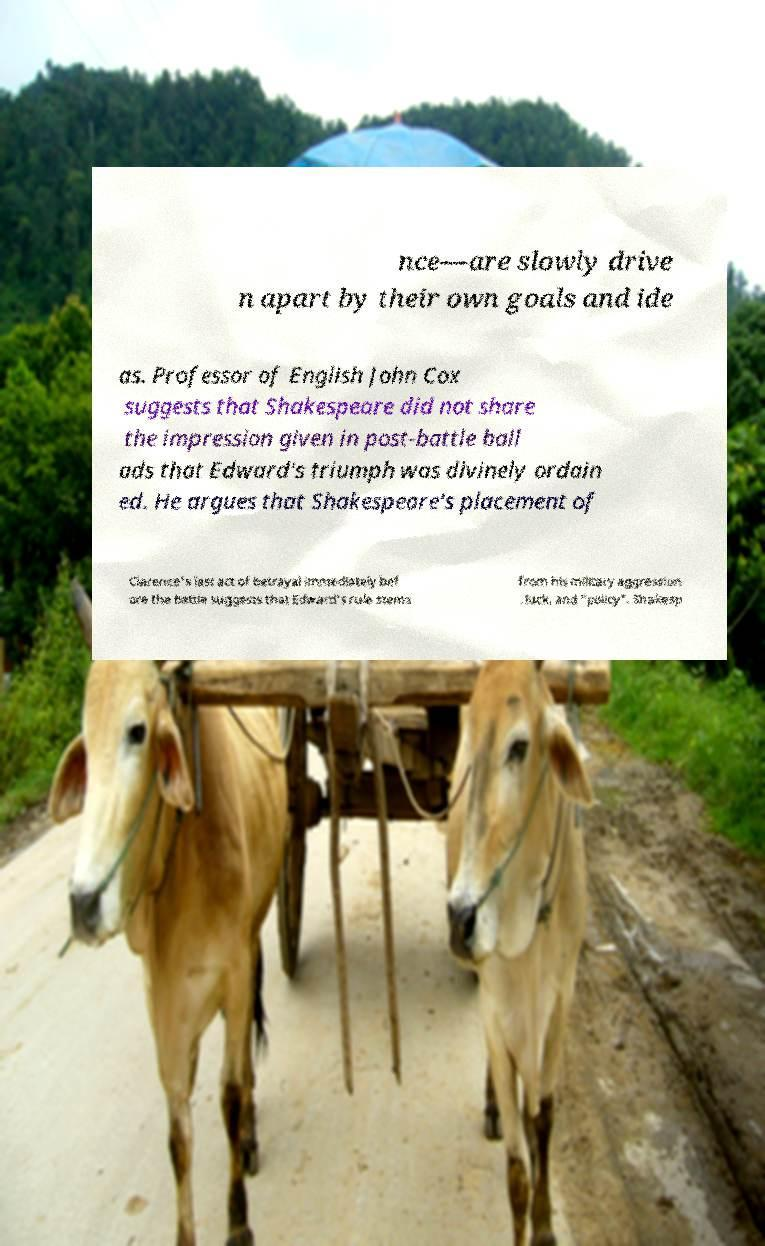Please identify and transcribe the text found in this image. nce—are slowly drive n apart by their own goals and ide as. Professor of English John Cox suggests that Shakespeare did not share the impression given in post-battle ball ads that Edward's triumph was divinely ordain ed. He argues that Shakespeare's placement of Clarence's last act of betrayal immediately bef ore the battle suggests that Edward's rule stems from his military aggression , luck, and "policy". Shakesp 